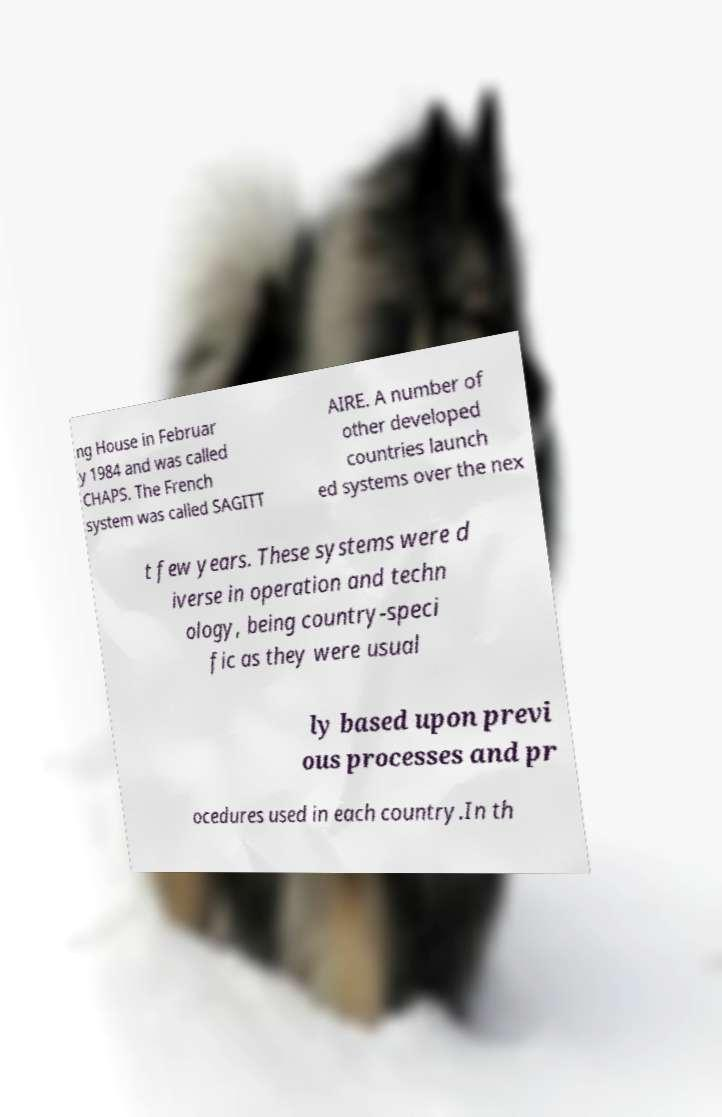There's text embedded in this image that I need extracted. Can you transcribe it verbatim? ng House in Februar y 1984 and was called CHAPS. The French system was called SAGITT AIRE. A number of other developed countries launch ed systems over the nex t few years. These systems were d iverse in operation and techn ology, being country-speci fic as they were usual ly based upon previ ous processes and pr ocedures used in each country.In th 